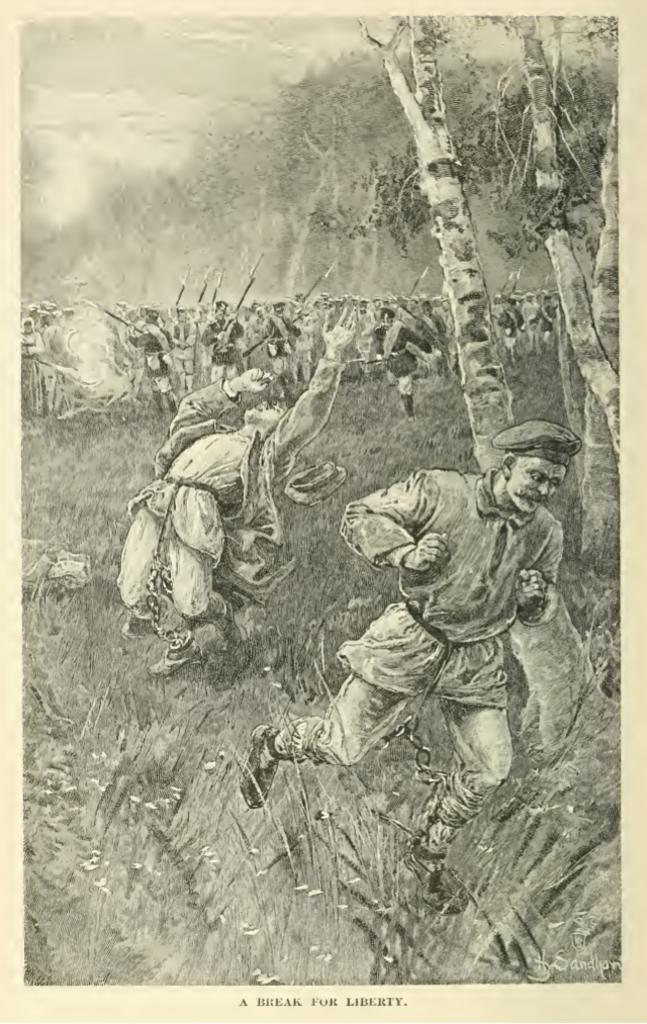Provide a one-sentence caption for the provided image. A black and white drawing shows men escaping and is titled a break for liberty. 